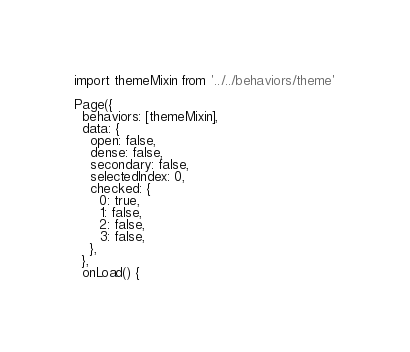Convert code to text. <code><loc_0><loc_0><loc_500><loc_500><_JavaScript_>import themeMixin from '../../behaviors/theme'

Page({
  behaviors: [themeMixin],
  data: {
    open: false,
    dense: false,
    secondary: false,
    selectedIndex: 0,
    checked: {
      0: true,
      1: false,
      2: false,
      3: false,
    },
  },
  onLoad() {</code> 